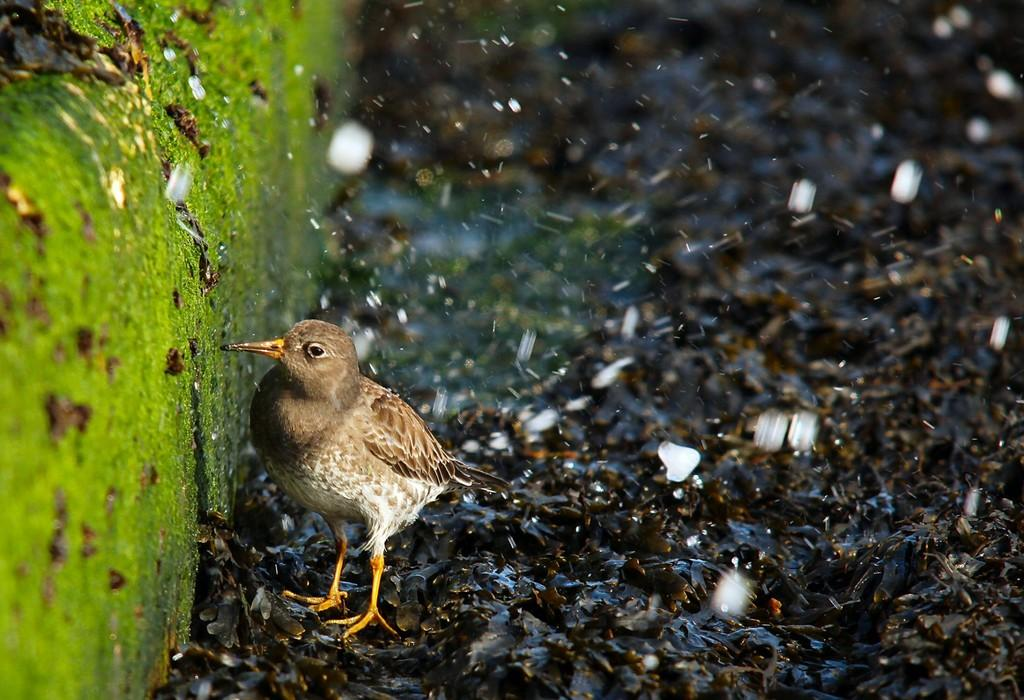What type of animal can be seen in the image? There is a bird on the surface in the image. What type of plant life is visible in the image? There is algae visible in the image. What type of caption is written on the bird in the image? There is no caption written on the bird in the image; it is a photograph of a bird and algae. 